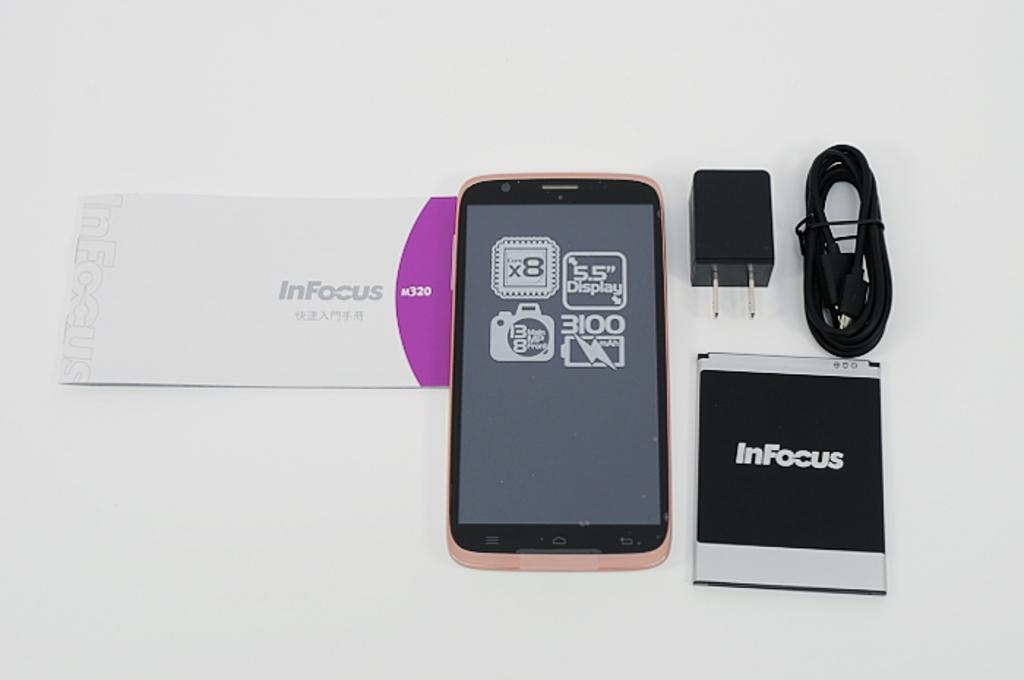<image>
Render a clear and concise summary of the photo. A complete set up for a smart phone with a box labeled Infocus. 